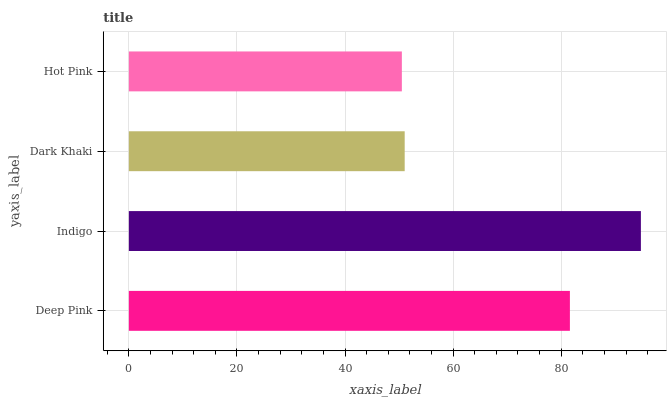Is Hot Pink the minimum?
Answer yes or no. Yes. Is Indigo the maximum?
Answer yes or no. Yes. Is Dark Khaki the minimum?
Answer yes or no. No. Is Dark Khaki the maximum?
Answer yes or no. No. Is Indigo greater than Dark Khaki?
Answer yes or no. Yes. Is Dark Khaki less than Indigo?
Answer yes or no. Yes. Is Dark Khaki greater than Indigo?
Answer yes or no. No. Is Indigo less than Dark Khaki?
Answer yes or no. No. Is Deep Pink the high median?
Answer yes or no. Yes. Is Dark Khaki the low median?
Answer yes or no. Yes. Is Indigo the high median?
Answer yes or no. No. Is Indigo the low median?
Answer yes or no. No. 